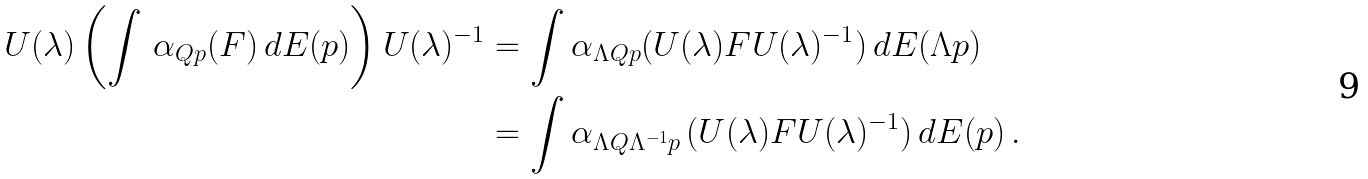<formula> <loc_0><loc_0><loc_500><loc_500>U ( \lambda ) \left ( \int \, \alpha _ { Q p } ( F ) \, d E ( p ) \right ) U ( \lambda ) ^ { - 1 } & = \int \alpha _ { \Lambda Q p } ( U ( \lambda ) F U ( \lambda ) ^ { - 1 } ) \, d E ( \Lambda p ) \\ & = \int \alpha _ { \Lambda Q \Lambda ^ { - 1 } p } \, ( U ( \lambda ) F U ( \lambda ) ^ { - 1 } ) \, d E ( p ) \, .</formula> 